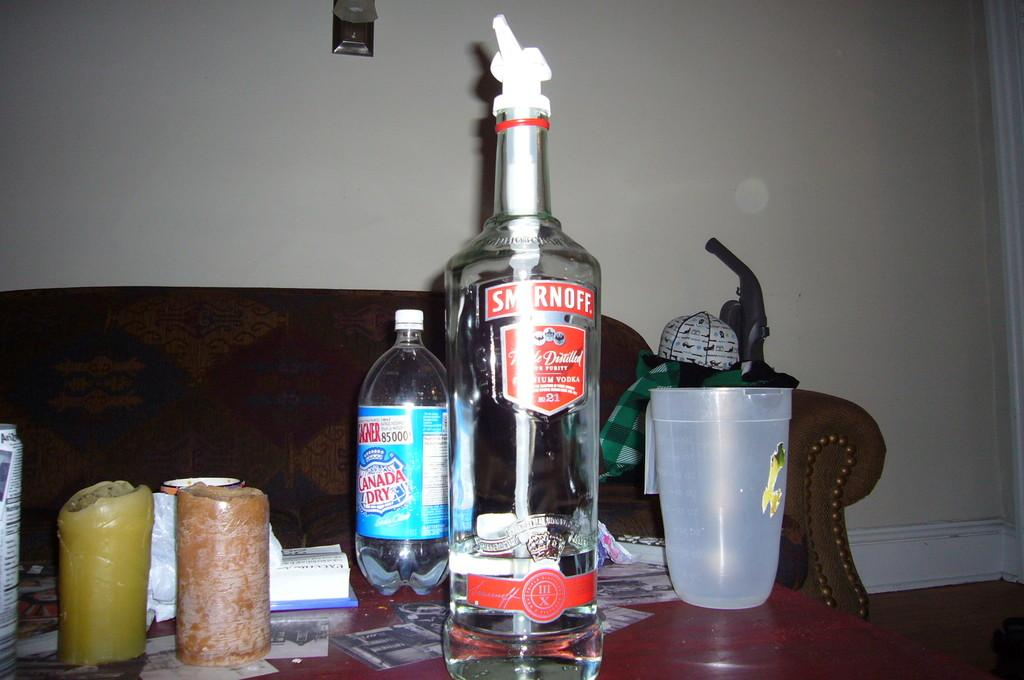Provide a one-sentence caption for the provided image. A bottle of Smirnoff on a coffee table is about one quater full. 